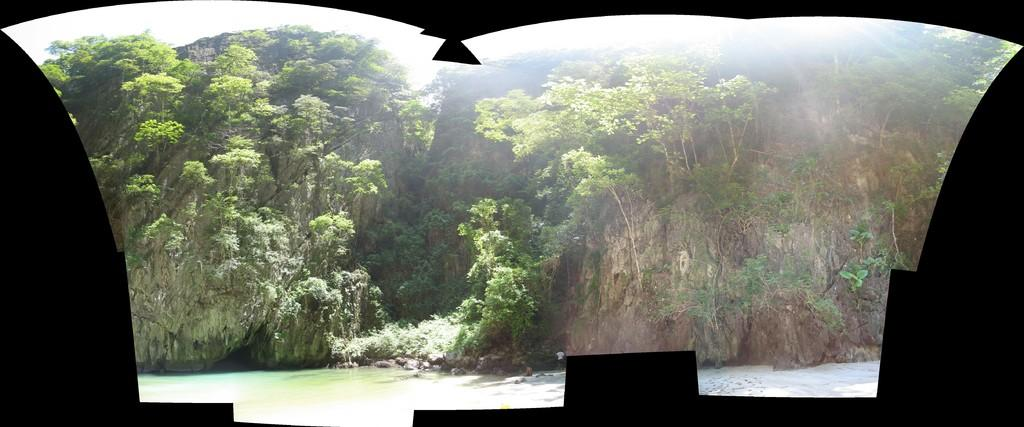What is the main subject in the center of the image? There is water in the center of the image. What can be seen in the background of the image? There are trees in the background of the image. What is the color and location of the object in the front of the image? There is a black sheet visible in the front of the image. How many mittens can be seen in the image? There are no mittens present in the image. What type of bushes are growing near the water in the image? There is no mention of bushes in the image; only trees are mentioned in the background. 